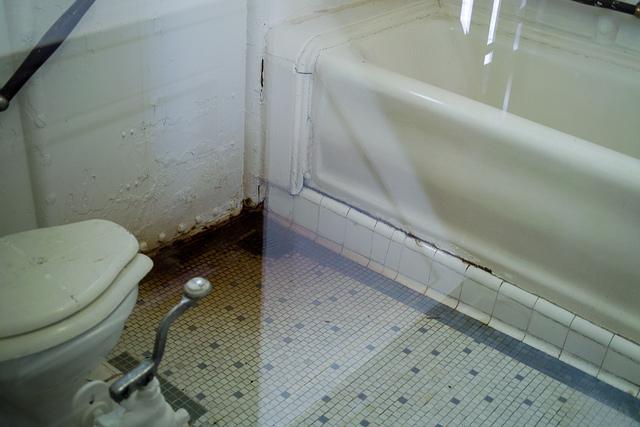Does this bathroom need to be renovated?
Give a very brief answer. Yes. Is there water in the tub?
Be succinct. No. Is there a reflection in the image?
Short answer required. Yes. Is the floor dirty?
Answer briefly. Yes. 